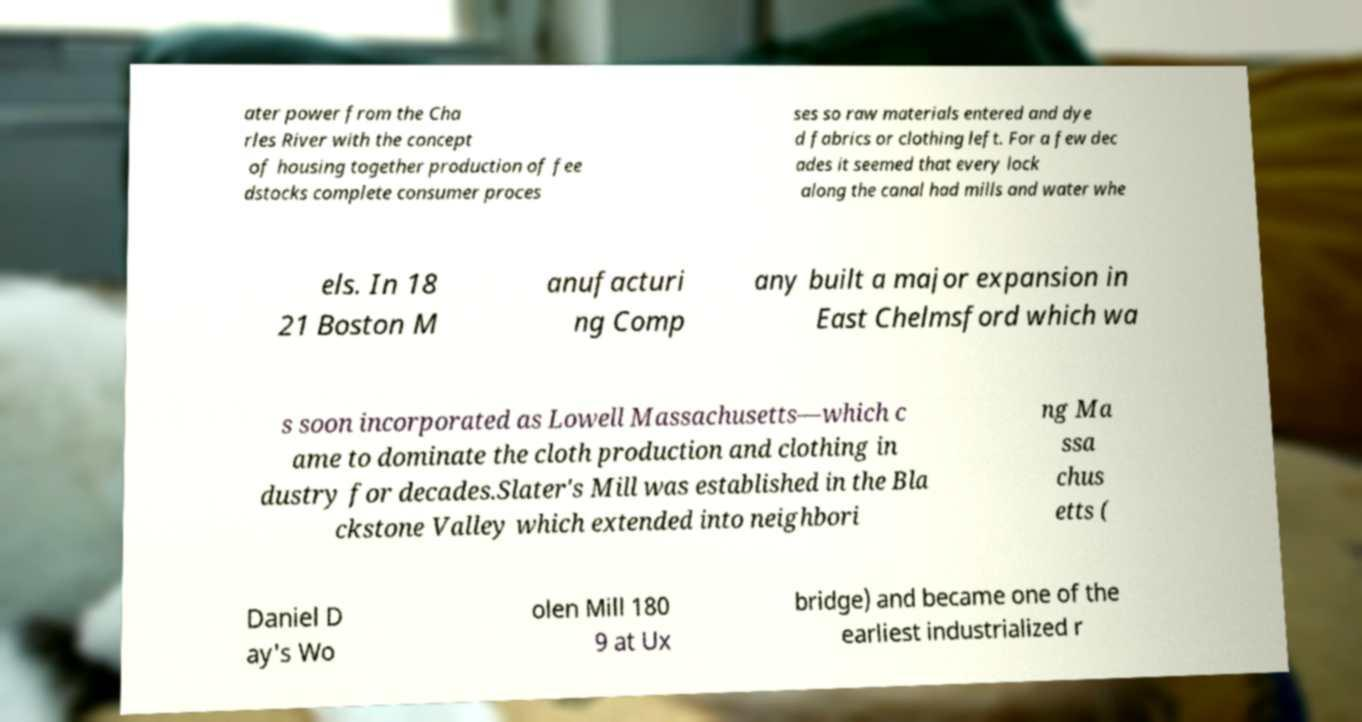Can you read and provide the text displayed in the image?This photo seems to have some interesting text. Can you extract and type it out for me? ater power from the Cha rles River with the concept of housing together production of fee dstocks complete consumer proces ses so raw materials entered and dye d fabrics or clothing left. For a few dec ades it seemed that every lock along the canal had mills and water whe els. In 18 21 Boston M anufacturi ng Comp any built a major expansion in East Chelmsford which wa s soon incorporated as Lowell Massachusetts—which c ame to dominate the cloth production and clothing in dustry for decades.Slater's Mill was established in the Bla ckstone Valley which extended into neighbori ng Ma ssa chus etts ( Daniel D ay's Wo olen Mill 180 9 at Ux bridge) and became one of the earliest industrialized r 